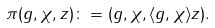Convert formula to latex. <formula><loc_0><loc_0><loc_500><loc_500>\pi ( g , \chi , z ) \colon = ( g , \chi , \langle g , \chi \rangle z ) .</formula> 